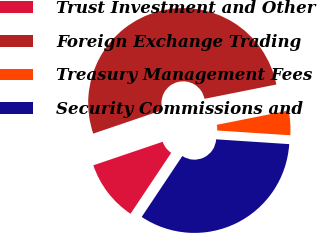Convert chart to OTSL. <chart><loc_0><loc_0><loc_500><loc_500><pie_chart><fcel>Trust Investment and Other<fcel>Foreign Exchange Trading<fcel>Treasury Management Fees<fcel>Security Commissions and<nl><fcel>10.42%<fcel>52.08%<fcel>4.17%<fcel>33.33%<nl></chart> 